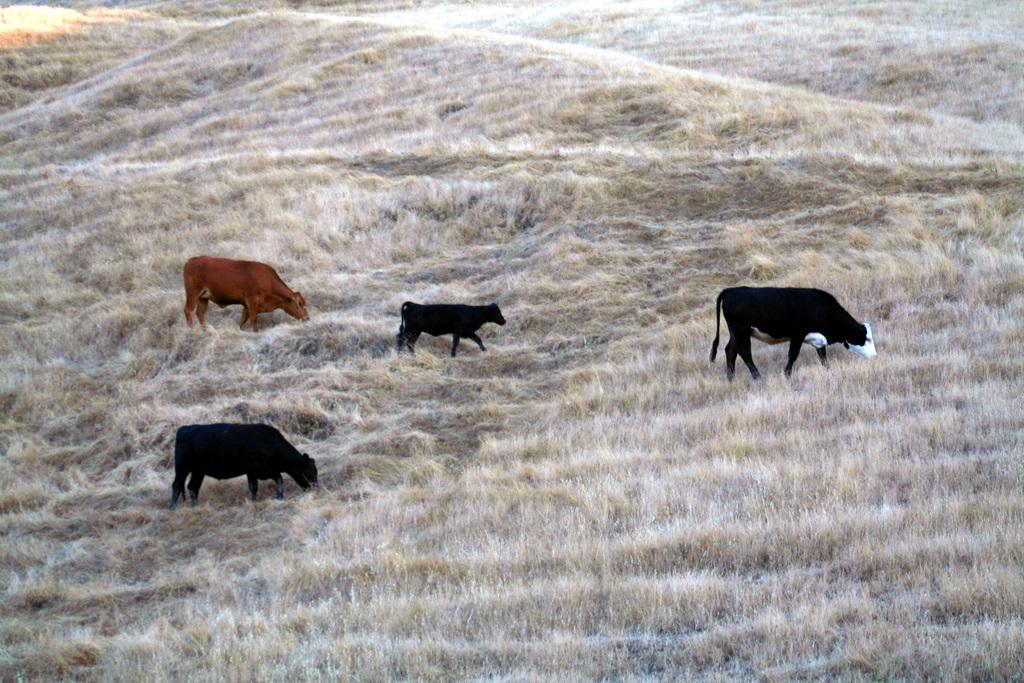How many cows are present in the image? There are four cows in the image. Where are the cows located? The cows are on the ground. What type of vegetation covers the ground in the image? The ground is covered with grass. What type of tank can be seen in the image? There is no tank present in the image; it features four cows on the grass-covered ground. What is the range of the cows' desires in the image? The image does not provide information about the cows' desires, so it cannot be determined from the image. 